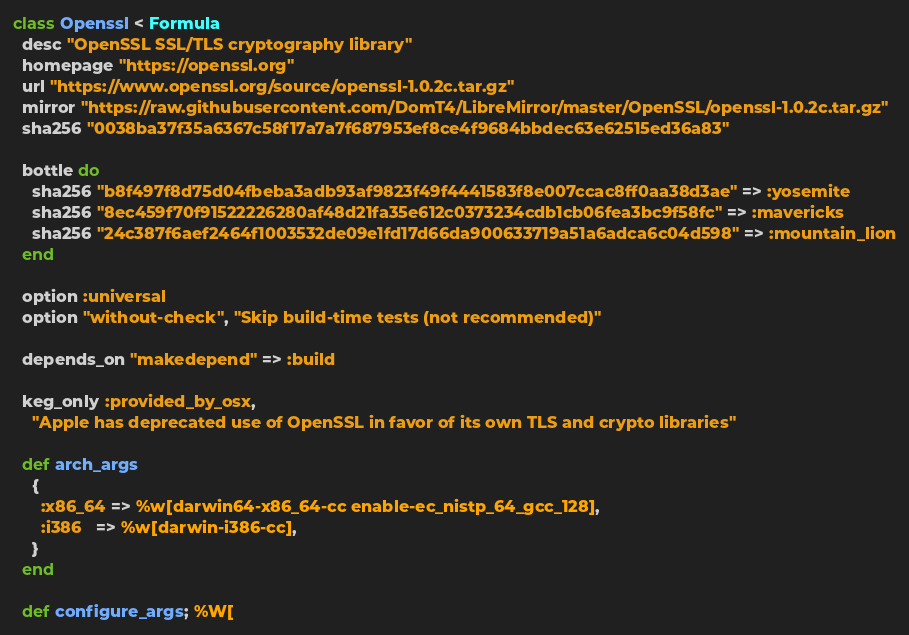<code> <loc_0><loc_0><loc_500><loc_500><_Ruby_>class Openssl < Formula
  desc "OpenSSL SSL/TLS cryptography library"
  homepage "https://openssl.org"
  url "https://www.openssl.org/source/openssl-1.0.2c.tar.gz"
  mirror "https://raw.githubusercontent.com/DomT4/LibreMirror/master/OpenSSL/openssl-1.0.2c.tar.gz"
  sha256 "0038ba37f35a6367c58f17a7a7f687953ef8ce4f9684bbdec63e62515ed36a83"

  bottle do
    sha256 "b8f497f8d75d04fbeba3adb93af9823f49f4441583f8e007ccac8ff0aa38d3ae" => :yosemite
    sha256 "8ec459f70f91522226280af48d21fa35e612c0373234cdb1cb06fea3bc9f58fc" => :mavericks
    sha256 "24c387f6aef2464f1003532de09e1fd17d66da900633719a51a6adca6c04d598" => :mountain_lion
  end

  option :universal
  option "without-check", "Skip build-time tests (not recommended)"

  depends_on "makedepend" => :build

  keg_only :provided_by_osx,
    "Apple has deprecated use of OpenSSL in favor of its own TLS and crypto libraries"

  def arch_args
    {
      :x86_64 => %w[darwin64-x86_64-cc enable-ec_nistp_64_gcc_128],
      :i386   => %w[darwin-i386-cc],
    }
  end

  def configure_args; %W[</code> 